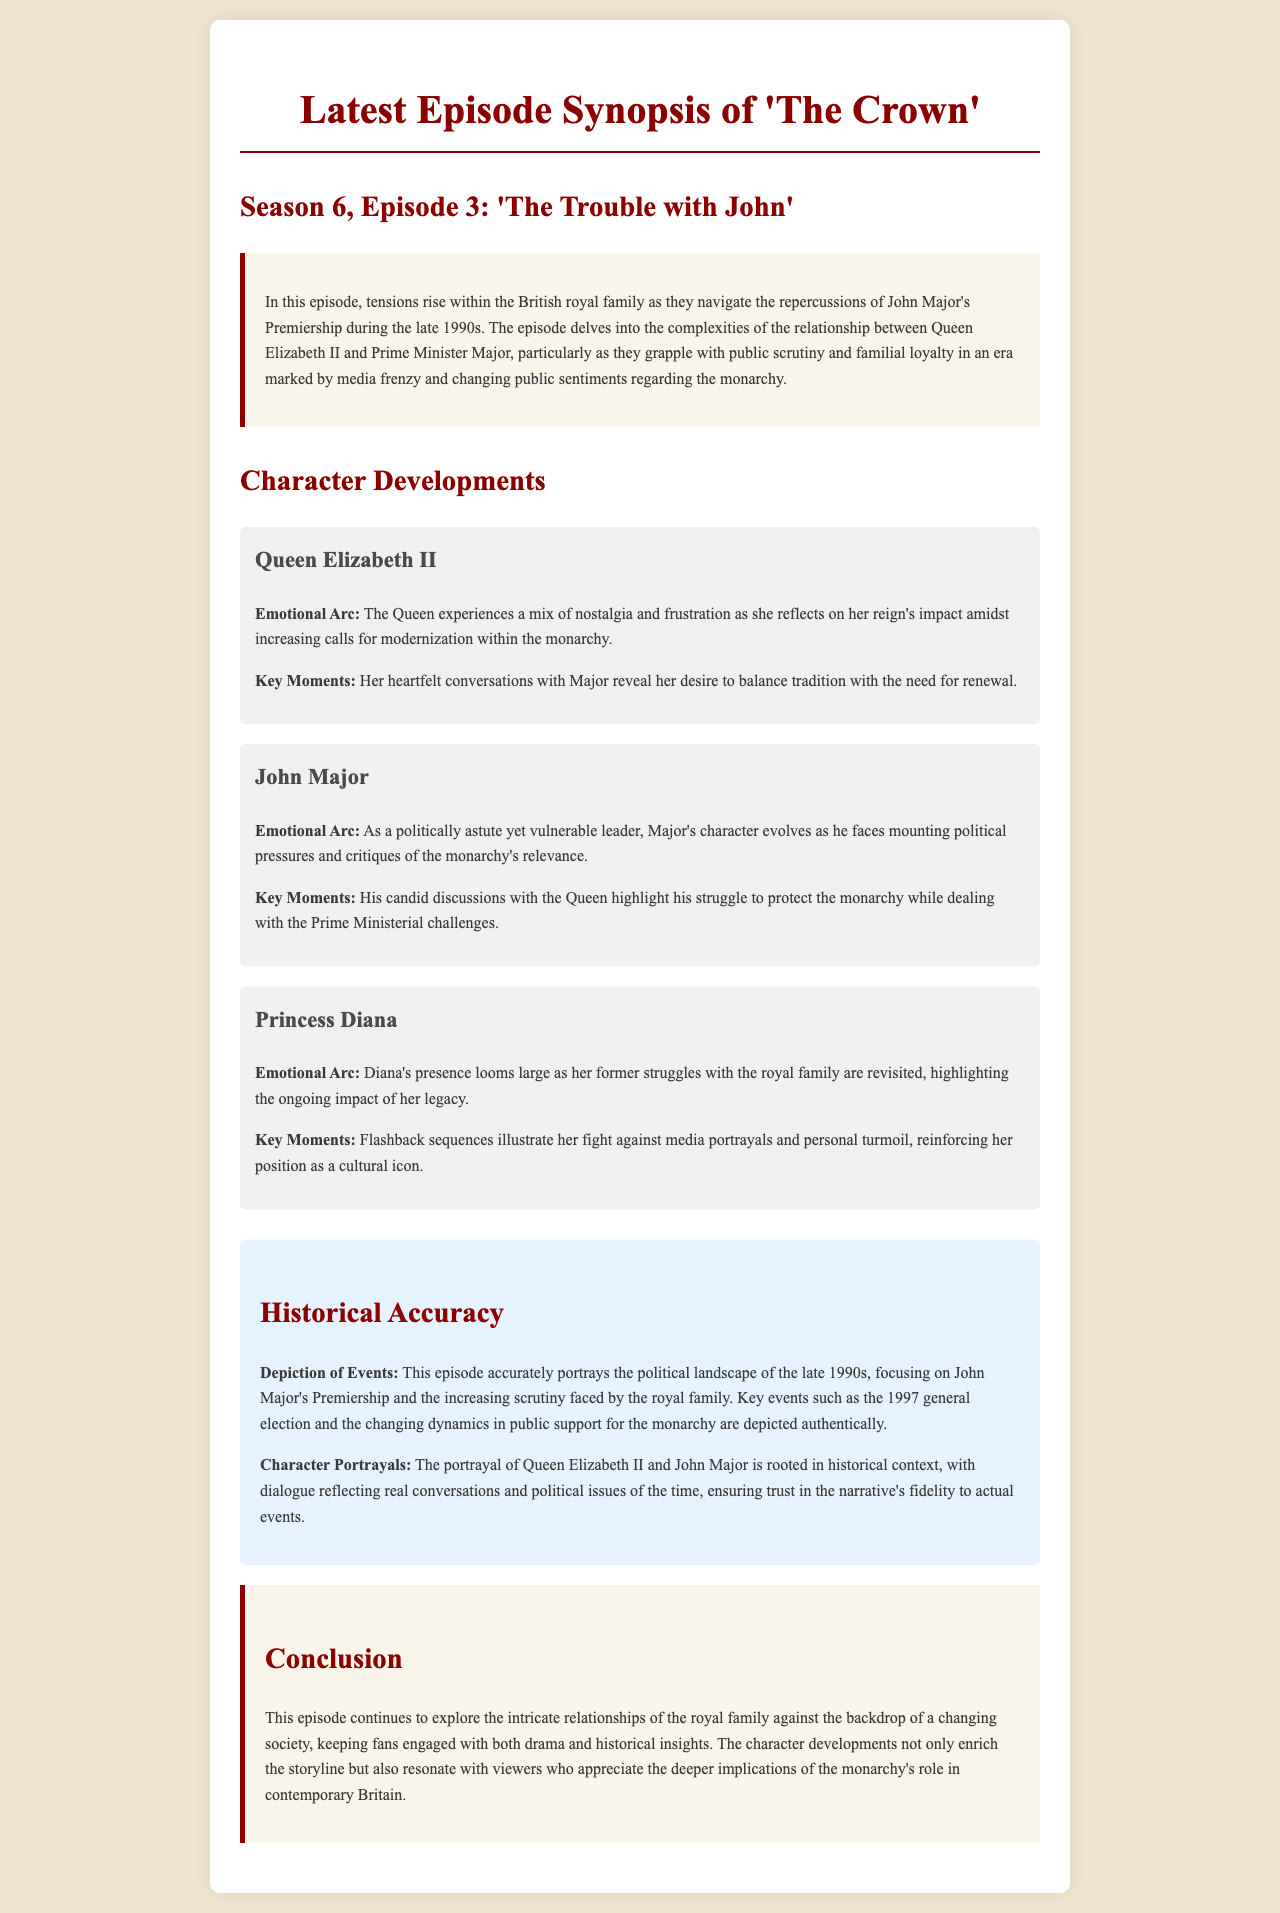What is the title of the latest episode? The title of the latest episode is mentioned at the beginning of the document as 'The Trouble with John'.
Answer: 'The Trouble with John' Who is the Prime Minister featured in this episode? The Prime Minister mentioned in the episode is John Major, who is a central character affecting the royal family dynamics.
Answer: John Major What emotional arc does Queen Elizabeth II experience? The emotional arc of Queen Elizabeth II includes nostalgia and frustration as she reflects on her reign.
Answer: Nostalgia and frustration Which historical period does this episode depict? The episode is set during the late 1990s, particularly focusing on the political landscape of that time.
Answer: Late 1990s What significant event from 1997 is mentioned in relation to the royal family? The document indicates that the 1997 general election is a key event referenced in the episode.
Answer: 1997 general election How does John Major's character evolve in this episode? John Major's character is portrayed as politically astute yet vulnerable, facing critiques of the monarchy’s relevance.
Answer: Politically astute yet vulnerable What role does Princess Diana's legacy play in this episode? The episode revisits Princess Diana's struggles with the royal family, emphasizing her lasting impact as a cultural icon.
Answer: Ongoing impact of her legacy What is the main theme explored in this episode? The main theme is the intricate relationships within the royal family set against a backdrop of changing societal views.
Answer: Changing societal views How does the episode ensure historical accuracy? The episode reflects real conversations and political dynamics of the late 1990s, maintaining fidelity to actual events.
Answer: Real conversations and political dynamics 